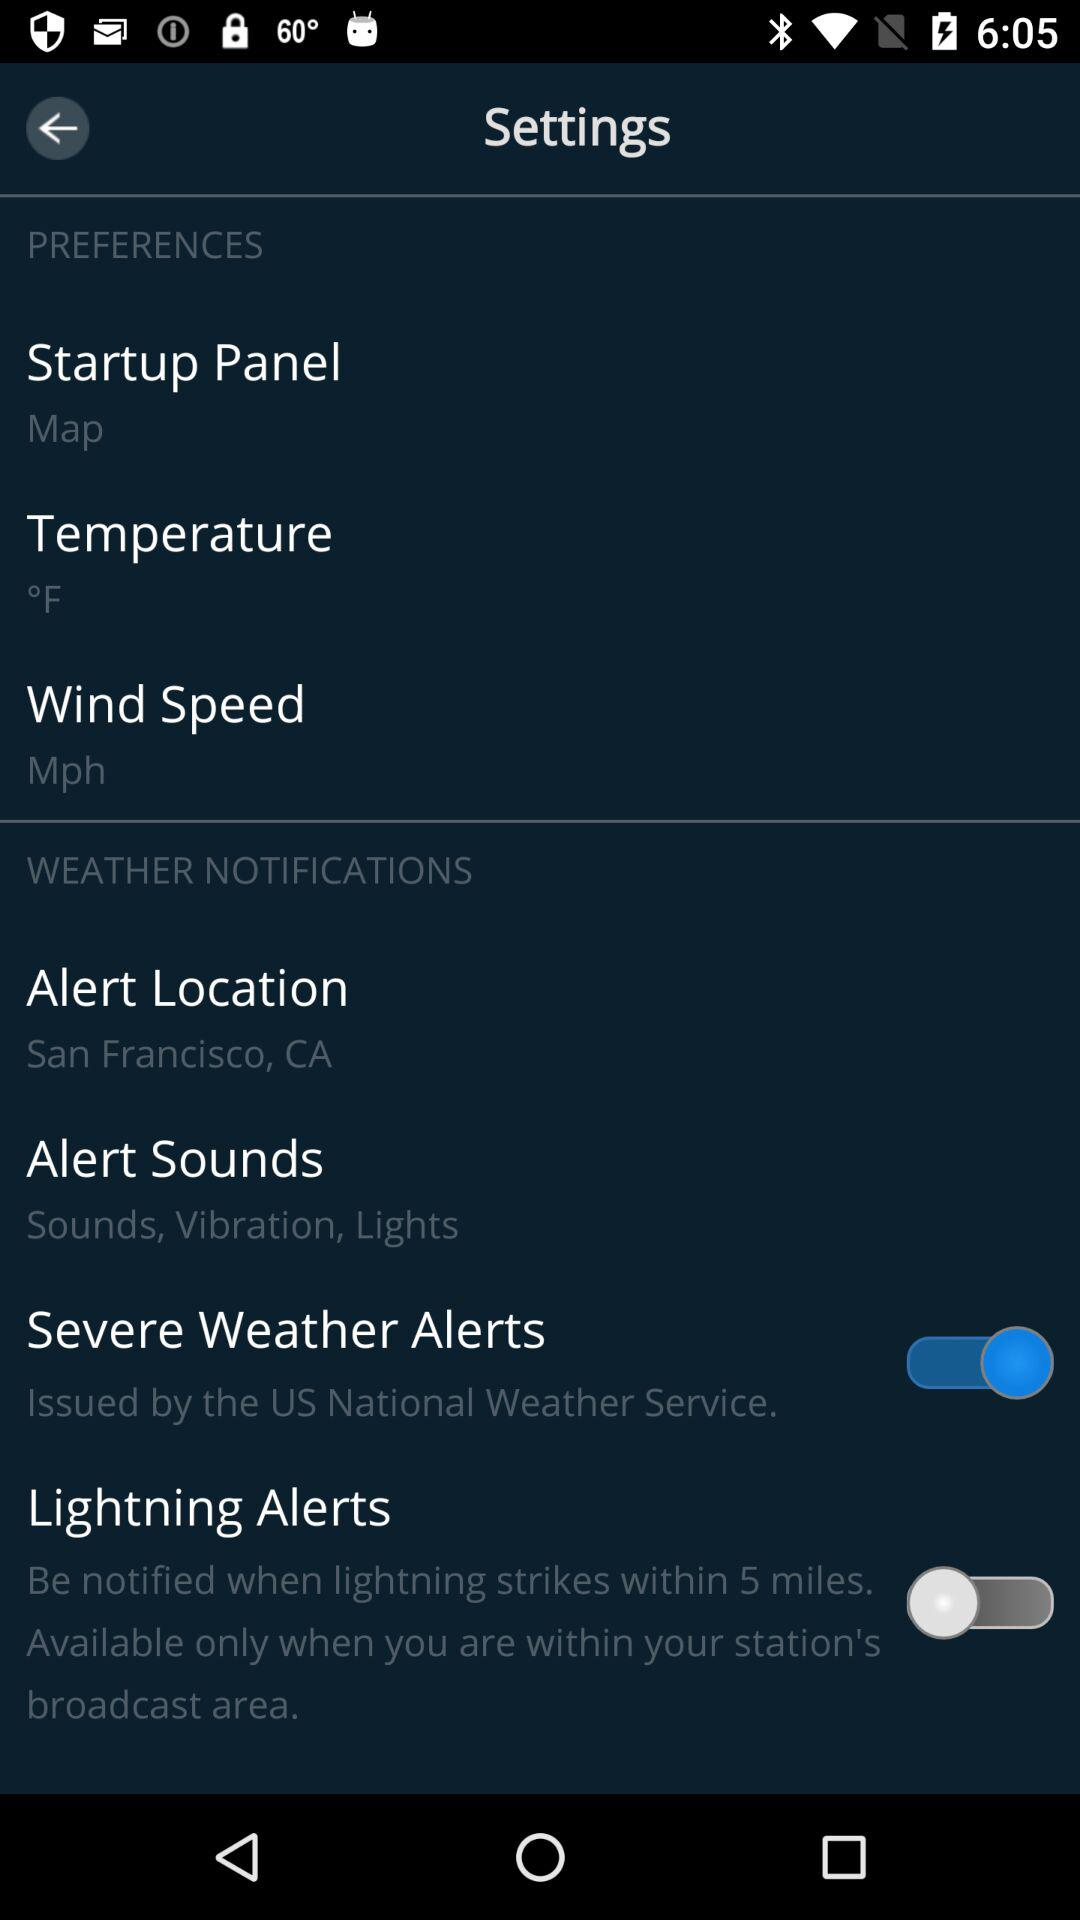What is the unit of temperature? The unit of temperature is °F. 